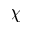Convert formula to latex. <formula><loc_0><loc_0><loc_500><loc_500>\chi</formula> 